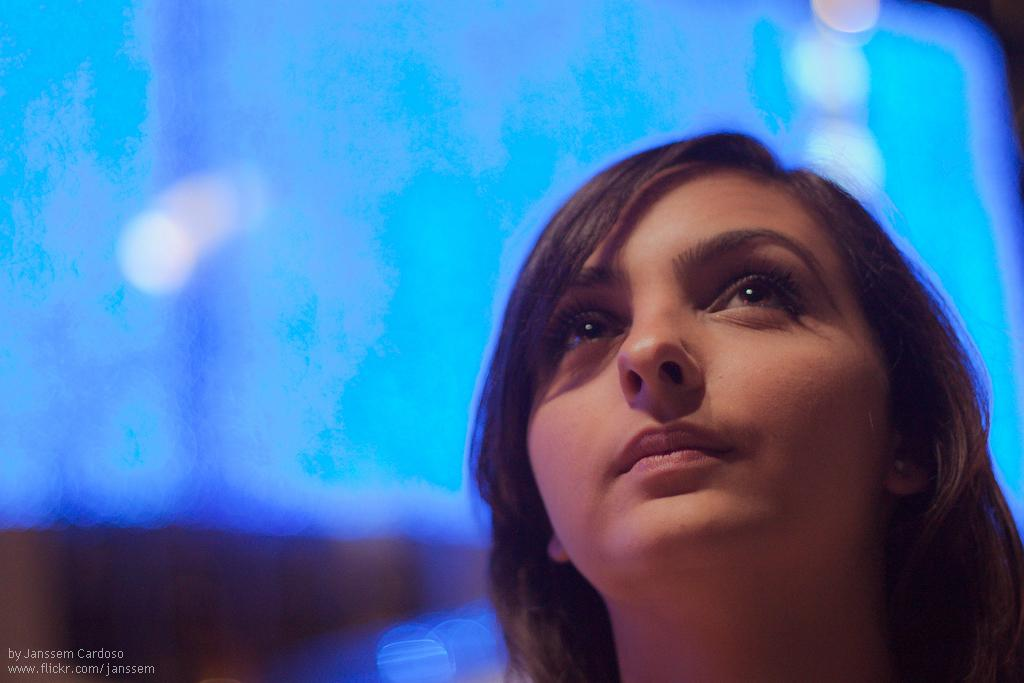Who is present in the image? There is a woman in the image. What is the woman's annual income in the image? There is no information provided about the woman's income in the image, so we cannot answer this question. 